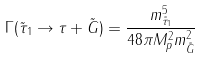Convert formula to latex. <formula><loc_0><loc_0><loc_500><loc_500>\Gamma ( \tilde { \tau } _ { 1 } \rightarrow \tau + \tilde { G } ) = \frac { m ^ { 5 } _ { \tilde { \tau } _ { 1 } } } { 4 8 \pi M ^ { 2 } _ { p } m ^ { 2 } _ { \tilde { G } } }</formula> 